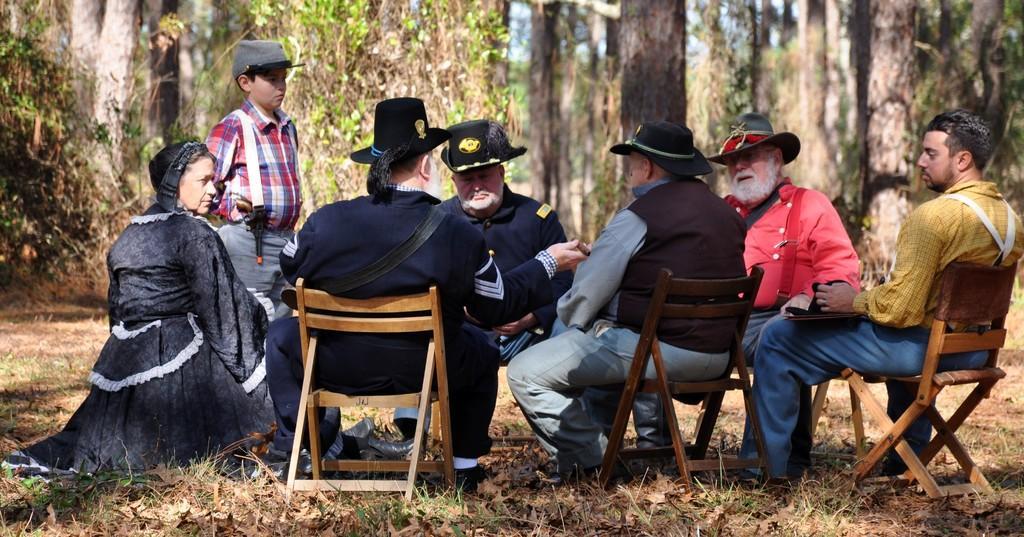In one or two sentences, can you explain what this image depicts? In this image i can see few people sitting on chairs wearing hats and a child standing in front of them. In the background i can see trees and sky. 